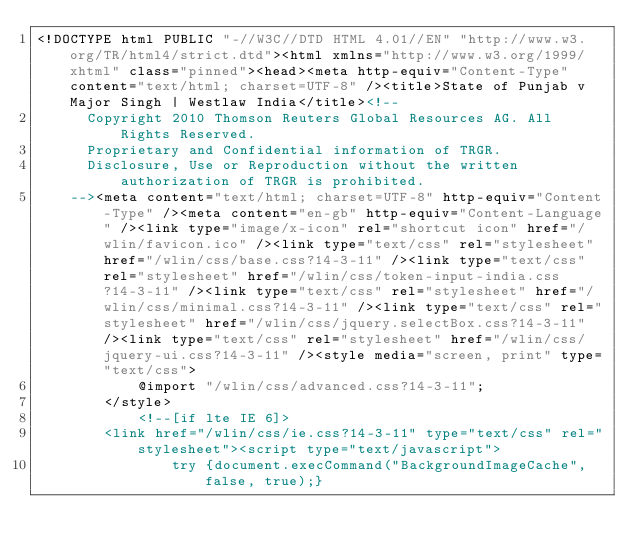Convert code to text. <code><loc_0><loc_0><loc_500><loc_500><_HTML_><!DOCTYPE html PUBLIC "-//W3C//DTD HTML 4.01//EN" "http://www.w3.org/TR/html4/strict.dtd"><html xmlns="http://www.w3.org/1999/xhtml" class="pinned"><head><meta http-equiv="Content-Type" content="text/html; charset=UTF-8" /><title>State of Punjab v Major Singh | Westlaw India</title><!--
      Copyright 2010 Thomson Reuters Global Resources AG. All Rights Reserved.
      Proprietary and Confidential information of TRGR.
      Disclosure, Use or Reproduction without the written authorization of TRGR is prohibited.
    --><meta content="text/html; charset=UTF-8" http-equiv="Content-Type" /><meta content="en-gb" http-equiv="Content-Language" /><link type="image/x-icon" rel="shortcut icon" href="/wlin/favicon.ico" /><link type="text/css" rel="stylesheet" href="/wlin/css/base.css?14-3-11" /><link type="text/css" rel="stylesheet" href="/wlin/css/token-input-india.css?14-3-11" /><link type="text/css" rel="stylesheet" href="/wlin/css/minimal.css?14-3-11" /><link type="text/css" rel="stylesheet" href="/wlin/css/jquery.selectBox.css?14-3-11" /><link type="text/css" rel="stylesheet" href="/wlin/css/jquery-ui.css?14-3-11" /><style media="screen, print" type="text/css">
			@import "/wlin/css/advanced.css?14-3-11";
		</style>
			<!--[if lte IE 6]>
		<link href="/wlin/css/ie.css?14-3-11" type="text/css" rel="stylesheet"><script type="text/javascript">
				try {document.execCommand("BackgroundImageCache", false, true);}</code> 